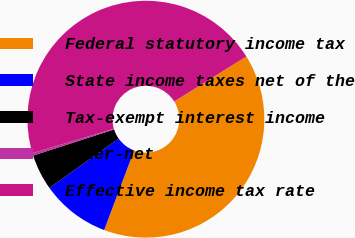Convert chart. <chart><loc_0><loc_0><loc_500><loc_500><pie_chart><fcel>Federal statutory income tax<fcel>State income taxes net of the<fcel>Tax-exempt interest income<fcel>Other-net<fcel>Effective income tax rate<nl><fcel>39.62%<fcel>9.42%<fcel>4.88%<fcel>0.34%<fcel>45.74%<nl></chart> 